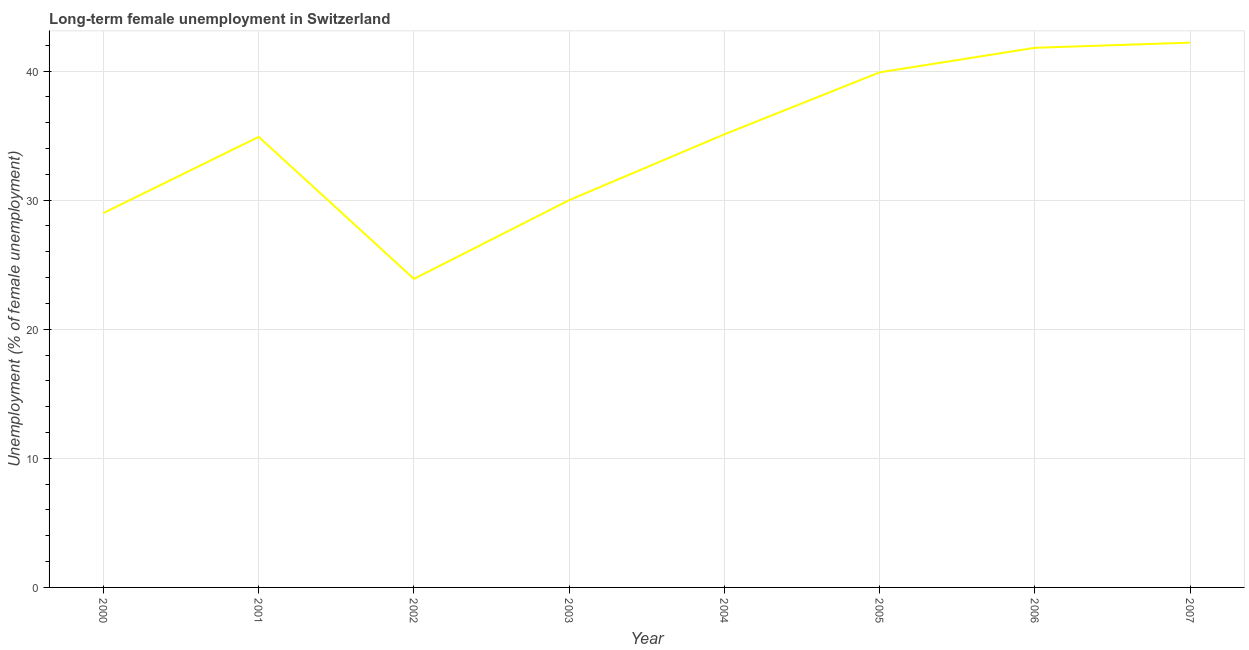Across all years, what is the maximum long-term female unemployment?
Offer a very short reply. 42.2. Across all years, what is the minimum long-term female unemployment?
Offer a very short reply. 23.9. In which year was the long-term female unemployment maximum?
Offer a terse response. 2007. What is the sum of the long-term female unemployment?
Provide a short and direct response. 276.8. What is the difference between the long-term female unemployment in 2000 and 2007?
Offer a terse response. -13.2. What is the average long-term female unemployment per year?
Your response must be concise. 34.6. What is the median long-term female unemployment?
Your answer should be compact. 35. In how many years, is the long-term female unemployment greater than 32 %?
Offer a very short reply. 5. Do a majority of the years between 2001 and 2004 (inclusive) have long-term female unemployment greater than 34 %?
Ensure brevity in your answer.  No. What is the ratio of the long-term female unemployment in 2003 to that in 2004?
Your answer should be very brief. 0.85. Is the long-term female unemployment in 2004 less than that in 2005?
Provide a succinct answer. Yes. What is the difference between the highest and the second highest long-term female unemployment?
Give a very brief answer. 0.4. Is the sum of the long-term female unemployment in 2001 and 2002 greater than the maximum long-term female unemployment across all years?
Offer a very short reply. Yes. What is the difference between the highest and the lowest long-term female unemployment?
Keep it short and to the point. 18.3. In how many years, is the long-term female unemployment greater than the average long-term female unemployment taken over all years?
Give a very brief answer. 5. Does the long-term female unemployment monotonically increase over the years?
Provide a short and direct response. No. How many years are there in the graph?
Offer a very short reply. 8. Are the values on the major ticks of Y-axis written in scientific E-notation?
Give a very brief answer. No. Does the graph contain any zero values?
Give a very brief answer. No. What is the title of the graph?
Offer a very short reply. Long-term female unemployment in Switzerland. What is the label or title of the X-axis?
Offer a terse response. Year. What is the label or title of the Y-axis?
Ensure brevity in your answer.  Unemployment (% of female unemployment). What is the Unemployment (% of female unemployment) in 2000?
Make the answer very short. 29. What is the Unemployment (% of female unemployment) of 2001?
Your answer should be very brief. 34.9. What is the Unemployment (% of female unemployment) in 2002?
Offer a very short reply. 23.9. What is the Unemployment (% of female unemployment) of 2004?
Offer a terse response. 35.1. What is the Unemployment (% of female unemployment) of 2005?
Ensure brevity in your answer.  39.9. What is the Unemployment (% of female unemployment) in 2006?
Offer a very short reply. 41.8. What is the Unemployment (% of female unemployment) of 2007?
Make the answer very short. 42.2. What is the difference between the Unemployment (% of female unemployment) in 2000 and 2002?
Give a very brief answer. 5.1. What is the difference between the Unemployment (% of female unemployment) in 2000 and 2005?
Your response must be concise. -10.9. What is the difference between the Unemployment (% of female unemployment) in 2001 and 2002?
Offer a terse response. 11. What is the difference between the Unemployment (% of female unemployment) in 2001 and 2005?
Provide a succinct answer. -5. What is the difference between the Unemployment (% of female unemployment) in 2001 and 2006?
Offer a very short reply. -6.9. What is the difference between the Unemployment (% of female unemployment) in 2001 and 2007?
Provide a short and direct response. -7.3. What is the difference between the Unemployment (% of female unemployment) in 2002 and 2003?
Offer a very short reply. -6.1. What is the difference between the Unemployment (% of female unemployment) in 2002 and 2005?
Keep it short and to the point. -16. What is the difference between the Unemployment (% of female unemployment) in 2002 and 2006?
Your answer should be compact. -17.9. What is the difference between the Unemployment (% of female unemployment) in 2002 and 2007?
Offer a terse response. -18.3. What is the difference between the Unemployment (% of female unemployment) in 2003 and 2004?
Give a very brief answer. -5.1. What is the difference between the Unemployment (% of female unemployment) in 2003 and 2005?
Your response must be concise. -9.9. What is the difference between the Unemployment (% of female unemployment) in 2003 and 2006?
Give a very brief answer. -11.8. What is the difference between the Unemployment (% of female unemployment) in 2005 and 2006?
Your answer should be very brief. -1.9. What is the difference between the Unemployment (% of female unemployment) in 2005 and 2007?
Make the answer very short. -2.3. What is the ratio of the Unemployment (% of female unemployment) in 2000 to that in 2001?
Ensure brevity in your answer.  0.83. What is the ratio of the Unemployment (% of female unemployment) in 2000 to that in 2002?
Ensure brevity in your answer.  1.21. What is the ratio of the Unemployment (% of female unemployment) in 2000 to that in 2003?
Provide a succinct answer. 0.97. What is the ratio of the Unemployment (% of female unemployment) in 2000 to that in 2004?
Give a very brief answer. 0.83. What is the ratio of the Unemployment (% of female unemployment) in 2000 to that in 2005?
Keep it short and to the point. 0.73. What is the ratio of the Unemployment (% of female unemployment) in 2000 to that in 2006?
Make the answer very short. 0.69. What is the ratio of the Unemployment (% of female unemployment) in 2000 to that in 2007?
Your answer should be compact. 0.69. What is the ratio of the Unemployment (% of female unemployment) in 2001 to that in 2002?
Your answer should be very brief. 1.46. What is the ratio of the Unemployment (% of female unemployment) in 2001 to that in 2003?
Your answer should be very brief. 1.16. What is the ratio of the Unemployment (% of female unemployment) in 2001 to that in 2005?
Your answer should be compact. 0.88. What is the ratio of the Unemployment (% of female unemployment) in 2001 to that in 2006?
Offer a very short reply. 0.83. What is the ratio of the Unemployment (% of female unemployment) in 2001 to that in 2007?
Keep it short and to the point. 0.83. What is the ratio of the Unemployment (% of female unemployment) in 2002 to that in 2003?
Provide a succinct answer. 0.8. What is the ratio of the Unemployment (% of female unemployment) in 2002 to that in 2004?
Your response must be concise. 0.68. What is the ratio of the Unemployment (% of female unemployment) in 2002 to that in 2005?
Give a very brief answer. 0.6. What is the ratio of the Unemployment (% of female unemployment) in 2002 to that in 2006?
Make the answer very short. 0.57. What is the ratio of the Unemployment (% of female unemployment) in 2002 to that in 2007?
Offer a terse response. 0.57. What is the ratio of the Unemployment (% of female unemployment) in 2003 to that in 2004?
Keep it short and to the point. 0.85. What is the ratio of the Unemployment (% of female unemployment) in 2003 to that in 2005?
Provide a short and direct response. 0.75. What is the ratio of the Unemployment (% of female unemployment) in 2003 to that in 2006?
Your response must be concise. 0.72. What is the ratio of the Unemployment (% of female unemployment) in 2003 to that in 2007?
Give a very brief answer. 0.71. What is the ratio of the Unemployment (% of female unemployment) in 2004 to that in 2005?
Make the answer very short. 0.88. What is the ratio of the Unemployment (% of female unemployment) in 2004 to that in 2006?
Make the answer very short. 0.84. What is the ratio of the Unemployment (% of female unemployment) in 2004 to that in 2007?
Your answer should be very brief. 0.83. What is the ratio of the Unemployment (% of female unemployment) in 2005 to that in 2006?
Keep it short and to the point. 0.95. What is the ratio of the Unemployment (% of female unemployment) in 2005 to that in 2007?
Keep it short and to the point. 0.94. What is the ratio of the Unemployment (% of female unemployment) in 2006 to that in 2007?
Give a very brief answer. 0.99. 